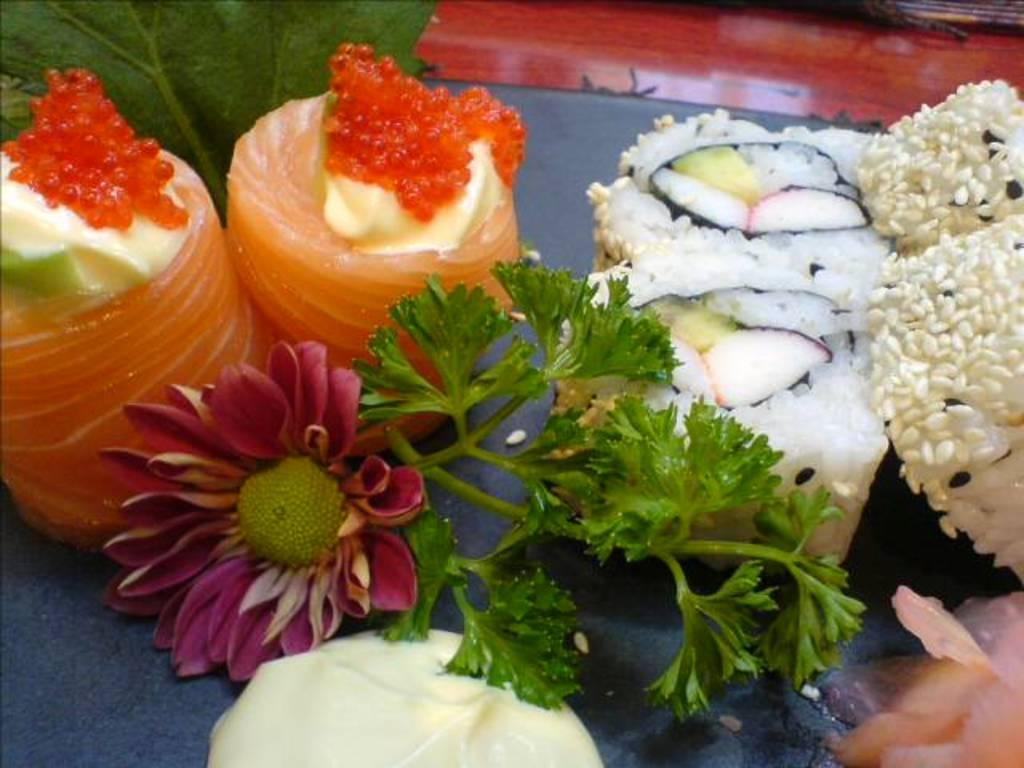What is the main subject of the image? There is a flower in the image. What else can be seen in the image besides the flower? There are food items on a table in the image. What word is written on the clouds in the image? There are no clouds or words present in the image. 